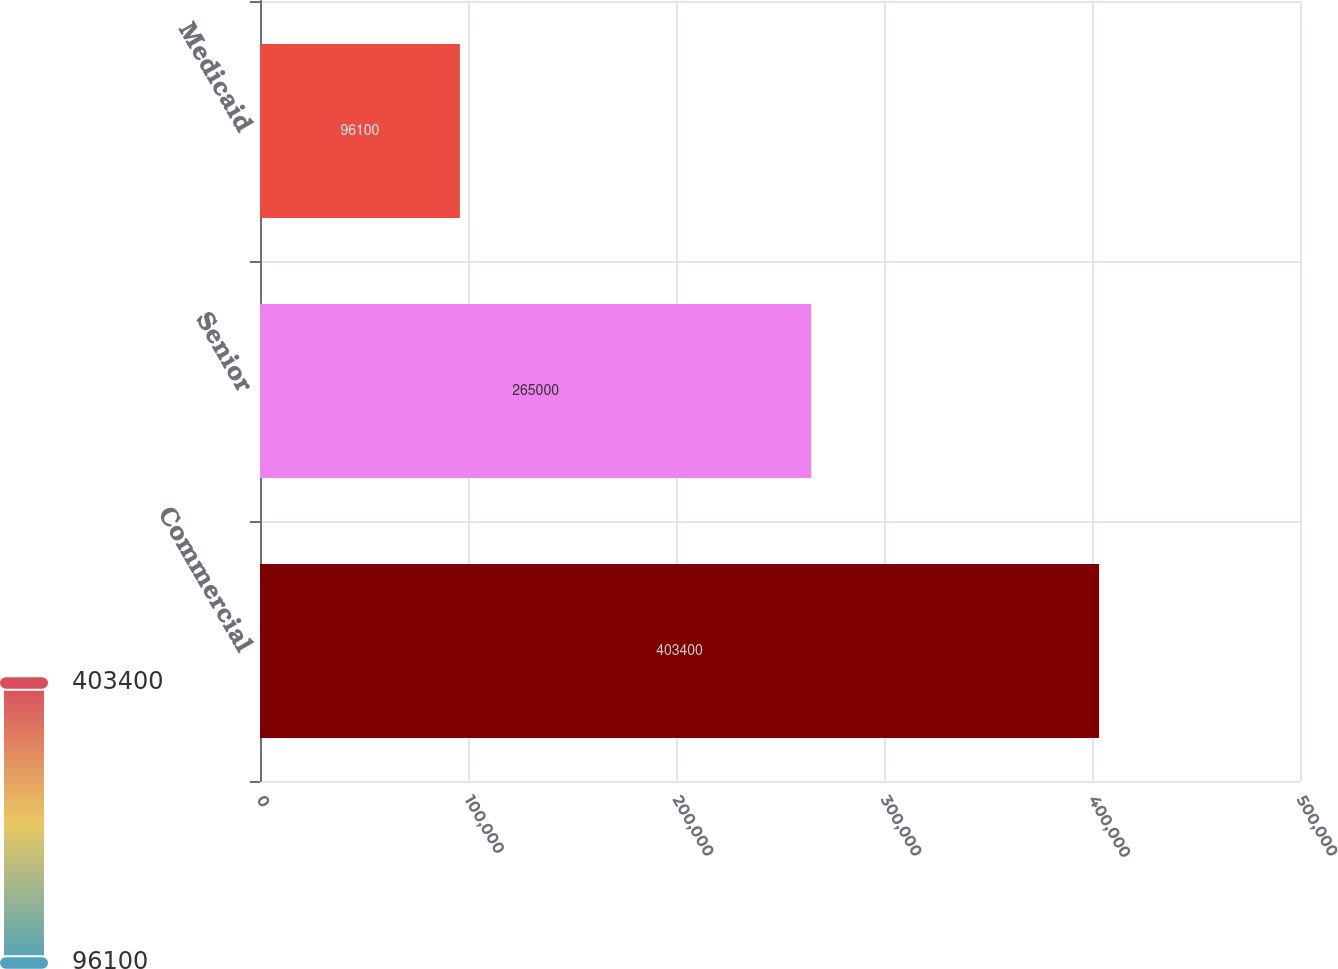<chart> <loc_0><loc_0><loc_500><loc_500><bar_chart><fcel>Commercial<fcel>Senior<fcel>Medicaid<nl><fcel>403400<fcel>265000<fcel>96100<nl></chart> 